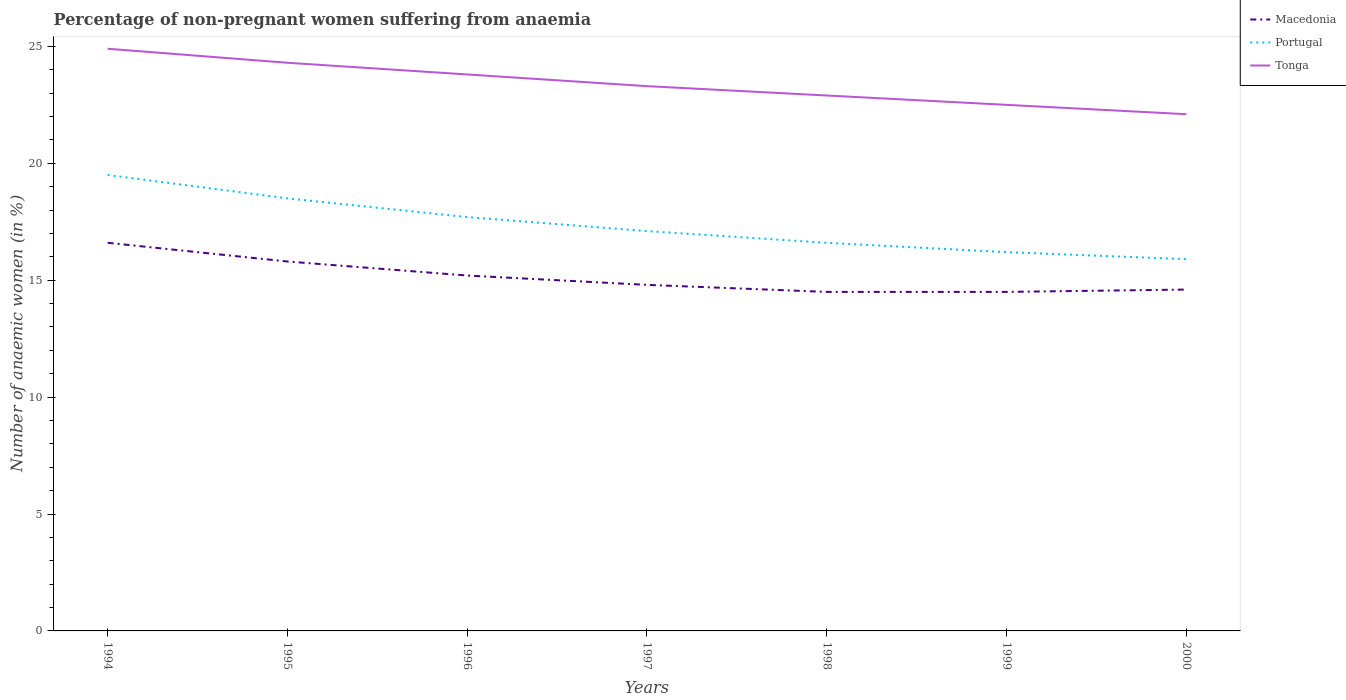How many different coloured lines are there?
Provide a short and direct response. 3. Is the number of lines equal to the number of legend labels?
Offer a very short reply. Yes. Across all years, what is the maximum percentage of non-pregnant women suffering from anaemia in Tonga?
Give a very brief answer. 22.1. What is the total percentage of non-pregnant women suffering from anaemia in Macedonia in the graph?
Keep it short and to the point. 1.4. What is the difference between the highest and the second highest percentage of non-pregnant women suffering from anaemia in Portugal?
Offer a very short reply. 3.6. How many years are there in the graph?
Make the answer very short. 7. What is the difference between two consecutive major ticks on the Y-axis?
Your answer should be very brief. 5. Does the graph contain any zero values?
Your answer should be very brief. No. Where does the legend appear in the graph?
Provide a short and direct response. Top right. How many legend labels are there?
Provide a succinct answer. 3. How are the legend labels stacked?
Keep it short and to the point. Vertical. What is the title of the graph?
Offer a very short reply. Percentage of non-pregnant women suffering from anaemia. What is the label or title of the Y-axis?
Offer a very short reply. Number of anaemic women (in %). What is the Number of anaemic women (in %) in Portugal in 1994?
Give a very brief answer. 19.5. What is the Number of anaemic women (in %) in Tonga in 1994?
Your answer should be very brief. 24.9. What is the Number of anaemic women (in %) of Macedonia in 1995?
Provide a short and direct response. 15.8. What is the Number of anaemic women (in %) of Tonga in 1995?
Your answer should be compact. 24.3. What is the Number of anaemic women (in %) in Macedonia in 1996?
Ensure brevity in your answer.  15.2. What is the Number of anaemic women (in %) in Tonga in 1996?
Make the answer very short. 23.8. What is the Number of anaemic women (in %) in Portugal in 1997?
Give a very brief answer. 17.1. What is the Number of anaemic women (in %) in Tonga in 1997?
Ensure brevity in your answer.  23.3. What is the Number of anaemic women (in %) in Macedonia in 1998?
Provide a short and direct response. 14.5. What is the Number of anaemic women (in %) of Portugal in 1998?
Your answer should be compact. 16.6. What is the Number of anaemic women (in %) in Tonga in 1998?
Ensure brevity in your answer.  22.9. What is the Number of anaemic women (in %) in Portugal in 1999?
Offer a very short reply. 16.2. What is the Number of anaemic women (in %) of Tonga in 2000?
Keep it short and to the point. 22.1. Across all years, what is the maximum Number of anaemic women (in %) of Macedonia?
Offer a terse response. 16.6. Across all years, what is the maximum Number of anaemic women (in %) in Portugal?
Keep it short and to the point. 19.5. Across all years, what is the maximum Number of anaemic women (in %) of Tonga?
Your answer should be compact. 24.9. Across all years, what is the minimum Number of anaemic women (in %) in Macedonia?
Provide a short and direct response. 14.5. Across all years, what is the minimum Number of anaemic women (in %) of Portugal?
Your answer should be compact. 15.9. Across all years, what is the minimum Number of anaemic women (in %) in Tonga?
Make the answer very short. 22.1. What is the total Number of anaemic women (in %) of Macedonia in the graph?
Keep it short and to the point. 106. What is the total Number of anaemic women (in %) in Portugal in the graph?
Keep it short and to the point. 121.5. What is the total Number of anaemic women (in %) of Tonga in the graph?
Offer a very short reply. 163.8. What is the difference between the Number of anaemic women (in %) in Tonga in 1994 and that in 1995?
Give a very brief answer. 0.6. What is the difference between the Number of anaemic women (in %) of Macedonia in 1994 and that in 1996?
Keep it short and to the point. 1.4. What is the difference between the Number of anaemic women (in %) of Portugal in 1994 and that in 1996?
Offer a very short reply. 1.8. What is the difference between the Number of anaemic women (in %) of Portugal in 1994 and that in 1997?
Provide a short and direct response. 2.4. What is the difference between the Number of anaemic women (in %) in Macedonia in 1994 and that in 1998?
Your response must be concise. 2.1. What is the difference between the Number of anaemic women (in %) of Portugal in 1994 and that in 1998?
Give a very brief answer. 2.9. What is the difference between the Number of anaemic women (in %) in Tonga in 1994 and that in 1998?
Give a very brief answer. 2. What is the difference between the Number of anaemic women (in %) in Portugal in 1994 and that in 1999?
Offer a terse response. 3.3. What is the difference between the Number of anaemic women (in %) in Portugal in 1995 and that in 1996?
Keep it short and to the point. 0.8. What is the difference between the Number of anaemic women (in %) in Tonga in 1995 and that in 1996?
Provide a succinct answer. 0.5. What is the difference between the Number of anaemic women (in %) in Macedonia in 1995 and that in 1997?
Ensure brevity in your answer.  1. What is the difference between the Number of anaemic women (in %) of Tonga in 1995 and that in 1997?
Provide a short and direct response. 1. What is the difference between the Number of anaemic women (in %) of Macedonia in 1995 and that in 1998?
Keep it short and to the point. 1.3. What is the difference between the Number of anaemic women (in %) of Macedonia in 1995 and that in 1999?
Your answer should be compact. 1.3. What is the difference between the Number of anaemic women (in %) in Tonga in 1995 and that in 1999?
Your answer should be compact. 1.8. What is the difference between the Number of anaemic women (in %) of Macedonia in 1995 and that in 2000?
Provide a short and direct response. 1.2. What is the difference between the Number of anaemic women (in %) of Tonga in 1995 and that in 2000?
Keep it short and to the point. 2.2. What is the difference between the Number of anaemic women (in %) in Tonga in 1996 and that in 1997?
Provide a short and direct response. 0.5. What is the difference between the Number of anaemic women (in %) of Portugal in 1996 and that in 1999?
Your response must be concise. 1.5. What is the difference between the Number of anaemic women (in %) of Tonga in 1996 and that in 1999?
Your answer should be very brief. 1.3. What is the difference between the Number of anaemic women (in %) of Macedonia in 1996 and that in 2000?
Give a very brief answer. 0.6. What is the difference between the Number of anaemic women (in %) in Tonga in 1997 and that in 1998?
Your answer should be very brief. 0.4. What is the difference between the Number of anaemic women (in %) in Macedonia in 1997 and that in 1999?
Ensure brevity in your answer.  0.3. What is the difference between the Number of anaemic women (in %) in Portugal in 1997 and that in 1999?
Give a very brief answer. 0.9. What is the difference between the Number of anaemic women (in %) in Tonga in 1997 and that in 1999?
Provide a succinct answer. 0.8. What is the difference between the Number of anaemic women (in %) of Macedonia in 1997 and that in 2000?
Make the answer very short. 0.2. What is the difference between the Number of anaemic women (in %) in Tonga in 1997 and that in 2000?
Your answer should be very brief. 1.2. What is the difference between the Number of anaemic women (in %) of Portugal in 1998 and that in 1999?
Provide a succinct answer. 0.4. What is the difference between the Number of anaemic women (in %) in Tonga in 1998 and that in 1999?
Give a very brief answer. 0.4. What is the difference between the Number of anaemic women (in %) of Tonga in 1998 and that in 2000?
Provide a succinct answer. 0.8. What is the difference between the Number of anaemic women (in %) in Macedonia in 1994 and the Number of anaemic women (in %) in Tonga in 1995?
Ensure brevity in your answer.  -7.7. What is the difference between the Number of anaemic women (in %) in Macedonia in 1994 and the Number of anaemic women (in %) in Portugal in 1996?
Your answer should be compact. -1.1. What is the difference between the Number of anaemic women (in %) in Macedonia in 1994 and the Number of anaemic women (in %) in Tonga in 1996?
Your response must be concise. -7.2. What is the difference between the Number of anaemic women (in %) of Macedonia in 1994 and the Number of anaemic women (in %) of Portugal in 1997?
Give a very brief answer. -0.5. What is the difference between the Number of anaemic women (in %) in Macedonia in 1994 and the Number of anaemic women (in %) in Tonga in 1997?
Offer a terse response. -6.7. What is the difference between the Number of anaemic women (in %) of Macedonia in 1994 and the Number of anaemic women (in %) of Portugal in 1998?
Ensure brevity in your answer.  0. What is the difference between the Number of anaemic women (in %) of Macedonia in 1994 and the Number of anaemic women (in %) of Tonga in 1999?
Your answer should be compact. -5.9. What is the difference between the Number of anaemic women (in %) in Macedonia in 1994 and the Number of anaemic women (in %) in Portugal in 2000?
Your answer should be very brief. 0.7. What is the difference between the Number of anaemic women (in %) in Portugal in 1994 and the Number of anaemic women (in %) in Tonga in 2000?
Offer a terse response. -2.6. What is the difference between the Number of anaemic women (in %) of Macedonia in 1995 and the Number of anaemic women (in %) of Tonga in 1996?
Keep it short and to the point. -8. What is the difference between the Number of anaemic women (in %) of Portugal in 1995 and the Number of anaemic women (in %) of Tonga in 1996?
Provide a succinct answer. -5.3. What is the difference between the Number of anaemic women (in %) of Macedonia in 1995 and the Number of anaemic women (in %) of Portugal in 1997?
Your answer should be very brief. -1.3. What is the difference between the Number of anaemic women (in %) of Macedonia in 1995 and the Number of anaemic women (in %) of Tonga in 1997?
Make the answer very short. -7.5. What is the difference between the Number of anaemic women (in %) in Macedonia in 1995 and the Number of anaemic women (in %) in Portugal in 1998?
Give a very brief answer. -0.8. What is the difference between the Number of anaemic women (in %) in Macedonia in 1995 and the Number of anaemic women (in %) in Tonga in 1998?
Offer a terse response. -7.1. What is the difference between the Number of anaemic women (in %) in Portugal in 1995 and the Number of anaemic women (in %) in Tonga in 1998?
Offer a terse response. -4.4. What is the difference between the Number of anaemic women (in %) of Portugal in 1995 and the Number of anaemic women (in %) of Tonga in 1999?
Provide a short and direct response. -4. What is the difference between the Number of anaemic women (in %) of Macedonia in 1995 and the Number of anaemic women (in %) of Portugal in 2000?
Give a very brief answer. -0.1. What is the difference between the Number of anaemic women (in %) of Macedonia in 1995 and the Number of anaemic women (in %) of Tonga in 2000?
Make the answer very short. -6.3. What is the difference between the Number of anaemic women (in %) of Macedonia in 1996 and the Number of anaemic women (in %) of Tonga in 1997?
Give a very brief answer. -8.1. What is the difference between the Number of anaemic women (in %) of Macedonia in 1996 and the Number of anaemic women (in %) of Tonga in 1998?
Provide a short and direct response. -7.7. What is the difference between the Number of anaemic women (in %) of Portugal in 1996 and the Number of anaemic women (in %) of Tonga in 1998?
Provide a succinct answer. -5.2. What is the difference between the Number of anaemic women (in %) of Macedonia in 1996 and the Number of anaemic women (in %) of Portugal in 2000?
Your answer should be very brief. -0.7. What is the difference between the Number of anaemic women (in %) of Macedonia in 1996 and the Number of anaemic women (in %) of Tonga in 2000?
Provide a short and direct response. -6.9. What is the difference between the Number of anaemic women (in %) in Portugal in 1996 and the Number of anaemic women (in %) in Tonga in 2000?
Ensure brevity in your answer.  -4.4. What is the difference between the Number of anaemic women (in %) of Macedonia in 1997 and the Number of anaemic women (in %) of Tonga in 1998?
Your answer should be very brief. -8.1. What is the difference between the Number of anaemic women (in %) of Portugal in 1997 and the Number of anaemic women (in %) of Tonga in 1999?
Your answer should be very brief. -5.4. What is the difference between the Number of anaemic women (in %) in Portugal in 1997 and the Number of anaemic women (in %) in Tonga in 2000?
Ensure brevity in your answer.  -5. What is the difference between the Number of anaemic women (in %) of Macedonia in 1998 and the Number of anaemic women (in %) of Portugal in 1999?
Your answer should be very brief. -1.7. What is the difference between the Number of anaemic women (in %) in Macedonia in 1998 and the Number of anaemic women (in %) in Tonga in 1999?
Provide a succinct answer. -8. What is the difference between the Number of anaemic women (in %) in Portugal in 1998 and the Number of anaemic women (in %) in Tonga in 1999?
Offer a terse response. -5.9. What is the difference between the Number of anaemic women (in %) in Macedonia in 1998 and the Number of anaemic women (in %) in Portugal in 2000?
Give a very brief answer. -1.4. What is the difference between the Number of anaemic women (in %) in Macedonia in 1998 and the Number of anaemic women (in %) in Tonga in 2000?
Offer a very short reply. -7.6. What is the difference between the Number of anaemic women (in %) of Portugal in 1998 and the Number of anaemic women (in %) of Tonga in 2000?
Your answer should be very brief. -5.5. What is the difference between the Number of anaemic women (in %) of Portugal in 1999 and the Number of anaemic women (in %) of Tonga in 2000?
Offer a terse response. -5.9. What is the average Number of anaemic women (in %) of Macedonia per year?
Your response must be concise. 15.14. What is the average Number of anaemic women (in %) in Portugal per year?
Your answer should be compact. 17.36. What is the average Number of anaemic women (in %) of Tonga per year?
Provide a succinct answer. 23.4. In the year 1994, what is the difference between the Number of anaemic women (in %) of Portugal and Number of anaemic women (in %) of Tonga?
Your answer should be very brief. -5.4. In the year 1995, what is the difference between the Number of anaemic women (in %) in Portugal and Number of anaemic women (in %) in Tonga?
Your answer should be compact. -5.8. In the year 1996, what is the difference between the Number of anaemic women (in %) in Macedonia and Number of anaemic women (in %) in Portugal?
Provide a succinct answer. -2.5. In the year 1996, what is the difference between the Number of anaemic women (in %) in Portugal and Number of anaemic women (in %) in Tonga?
Give a very brief answer. -6.1. In the year 1997, what is the difference between the Number of anaemic women (in %) in Macedonia and Number of anaemic women (in %) in Portugal?
Keep it short and to the point. -2.3. In the year 1997, what is the difference between the Number of anaemic women (in %) of Macedonia and Number of anaemic women (in %) of Tonga?
Provide a short and direct response. -8.5. In the year 1998, what is the difference between the Number of anaemic women (in %) in Macedonia and Number of anaemic women (in %) in Tonga?
Provide a short and direct response. -8.4. In the year 1999, what is the difference between the Number of anaemic women (in %) in Macedonia and Number of anaemic women (in %) in Portugal?
Offer a very short reply. -1.7. In the year 1999, what is the difference between the Number of anaemic women (in %) in Macedonia and Number of anaemic women (in %) in Tonga?
Keep it short and to the point. -8. In the year 1999, what is the difference between the Number of anaemic women (in %) of Portugal and Number of anaemic women (in %) of Tonga?
Make the answer very short. -6.3. In the year 2000, what is the difference between the Number of anaemic women (in %) of Portugal and Number of anaemic women (in %) of Tonga?
Keep it short and to the point. -6.2. What is the ratio of the Number of anaemic women (in %) of Macedonia in 1994 to that in 1995?
Your answer should be very brief. 1.05. What is the ratio of the Number of anaemic women (in %) in Portugal in 1994 to that in 1995?
Provide a succinct answer. 1.05. What is the ratio of the Number of anaemic women (in %) of Tonga in 1994 to that in 1995?
Offer a very short reply. 1.02. What is the ratio of the Number of anaemic women (in %) in Macedonia in 1994 to that in 1996?
Make the answer very short. 1.09. What is the ratio of the Number of anaemic women (in %) of Portugal in 1994 to that in 1996?
Provide a short and direct response. 1.1. What is the ratio of the Number of anaemic women (in %) of Tonga in 1994 to that in 1996?
Offer a very short reply. 1.05. What is the ratio of the Number of anaemic women (in %) in Macedonia in 1994 to that in 1997?
Provide a short and direct response. 1.12. What is the ratio of the Number of anaemic women (in %) of Portugal in 1994 to that in 1997?
Your answer should be compact. 1.14. What is the ratio of the Number of anaemic women (in %) of Tonga in 1994 to that in 1997?
Make the answer very short. 1.07. What is the ratio of the Number of anaemic women (in %) of Macedonia in 1994 to that in 1998?
Your response must be concise. 1.14. What is the ratio of the Number of anaemic women (in %) of Portugal in 1994 to that in 1998?
Keep it short and to the point. 1.17. What is the ratio of the Number of anaemic women (in %) in Tonga in 1994 to that in 1998?
Provide a succinct answer. 1.09. What is the ratio of the Number of anaemic women (in %) of Macedonia in 1994 to that in 1999?
Your response must be concise. 1.14. What is the ratio of the Number of anaemic women (in %) in Portugal in 1994 to that in 1999?
Offer a terse response. 1.2. What is the ratio of the Number of anaemic women (in %) in Tonga in 1994 to that in 1999?
Offer a terse response. 1.11. What is the ratio of the Number of anaemic women (in %) of Macedonia in 1994 to that in 2000?
Provide a succinct answer. 1.14. What is the ratio of the Number of anaemic women (in %) of Portugal in 1994 to that in 2000?
Ensure brevity in your answer.  1.23. What is the ratio of the Number of anaemic women (in %) in Tonga in 1994 to that in 2000?
Your answer should be compact. 1.13. What is the ratio of the Number of anaemic women (in %) in Macedonia in 1995 to that in 1996?
Keep it short and to the point. 1.04. What is the ratio of the Number of anaemic women (in %) in Portugal in 1995 to that in 1996?
Your response must be concise. 1.05. What is the ratio of the Number of anaemic women (in %) in Macedonia in 1995 to that in 1997?
Ensure brevity in your answer.  1.07. What is the ratio of the Number of anaemic women (in %) of Portugal in 1995 to that in 1997?
Provide a short and direct response. 1.08. What is the ratio of the Number of anaemic women (in %) in Tonga in 1995 to that in 1997?
Make the answer very short. 1.04. What is the ratio of the Number of anaemic women (in %) in Macedonia in 1995 to that in 1998?
Provide a short and direct response. 1.09. What is the ratio of the Number of anaemic women (in %) in Portugal in 1995 to that in 1998?
Provide a succinct answer. 1.11. What is the ratio of the Number of anaemic women (in %) of Tonga in 1995 to that in 1998?
Your response must be concise. 1.06. What is the ratio of the Number of anaemic women (in %) in Macedonia in 1995 to that in 1999?
Give a very brief answer. 1.09. What is the ratio of the Number of anaemic women (in %) of Portugal in 1995 to that in 1999?
Give a very brief answer. 1.14. What is the ratio of the Number of anaemic women (in %) in Macedonia in 1995 to that in 2000?
Offer a very short reply. 1.08. What is the ratio of the Number of anaemic women (in %) of Portugal in 1995 to that in 2000?
Give a very brief answer. 1.16. What is the ratio of the Number of anaemic women (in %) in Tonga in 1995 to that in 2000?
Provide a succinct answer. 1.1. What is the ratio of the Number of anaemic women (in %) of Portugal in 1996 to that in 1997?
Give a very brief answer. 1.04. What is the ratio of the Number of anaemic women (in %) of Tonga in 1996 to that in 1997?
Keep it short and to the point. 1.02. What is the ratio of the Number of anaemic women (in %) of Macedonia in 1996 to that in 1998?
Keep it short and to the point. 1.05. What is the ratio of the Number of anaemic women (in %) of Portugal in 1996 to that in 1998?
Offer a very short reply. 1.07. What is the ratio of the Number of anaemic women (in %) in Tonga in 1996 to that in 1998?
Your response must be concise. 1.04. What is the ratio of the Number of anaemic women (in %) of Macedonia in 1996 to that in 1999?
Your answer should be very brief. 1.05. What is the ratio of the Number of anaemic women (in %) of Portugal in 1996 to that in 1999?
Ensure brevity in your answer.  1.09. What is the ratio of the Number of anaemic women (in %) of Tonga in 1996 to that in 1999?
Provide a succinct answer. 1.06. What is the ratio of the Number of anaemic women (in %) of Macedonia in 1996 to that in 2000?
Keep it short and to the point. 1.04. What is the ratio of the Number of anaemic women (in %) of Portugal in 1996 to that in 2000?
Your answer should be compact. 1.11. What is the ratio of the Number of anaemic women (in %) of Tonga in 1996 to that in 2000?
Offer a terse response. 1.08. What is the ratio of the Number of anaemic women (in %) of Macedonia in 1997 to that in 1998?
Your answer should be very brief. 1.02. What is the ratio of the Number of anaemic women (in %) of Portugal in 1997 to that in 1998?
Your response must be concise. 1.03. What is the ratio of the Number of anaemic women (in %) of Tonga in 1997 to that in 1998?
Your answer should be compact. 1.02. What is the ratio of the Number of anaemic women (in %) of Macedonia in 1997 to that in 1999?
Give a very brief answer. 1.02. What is the ratio of the Number of anaemic women (in %) of Portugal in 1997 to that in 1999?
Your answer should be very brief. 1.06. What is the ratio of the Number of anaemic women (in %) of Tonga in 1997 to that in 1999?
Offer a terse response. 1.04. What is the ratio of the Number of anaemic women (in %) of Macedonia in 1997 to that in 2000?
Your answer should be compact. 1.01. What is the ratio of the Number of anaemic women (in %) in Portugal in 1997 to that in 2000?
Provide a succinct answer. 1.08. What is the ratio of the Number of anaemic women (in %) of Tonga in 1997 to that in 2000?
Make the answer very short. 1.05. What is the ratio of the Number of anaemic women (in %) in Portugal in 1998 to that in 1999?
Your answer should be very brief. 1.02. What is the ratio of the Number of anaemic women (in %) in Tonga in 1998 to that in 1999?
Give a very brief answer. 1.02. What is the ratio of the Number of anaemic women (in %) in Portugal in 1998 to that in 2000?
Provide a short and direct response. 1.04. What is the ratio of the Number of anaemic women (in %) in Tonga in 1998 to that in 2000?
Provide a short and direct response. 1.04. What is the ratio of the Number of anaemic women (in %) of Macedonia in 1999 to that in 2000?
Your answer should be very brief. 0.99. What is the ratio of the Number of anaemic women (in %) in Portugal in 1999 to that in 2000?
Make the answer very short. 1.02. What is the ratio of the Number of anaemic women (in %) in Tonga in 1999 to that in 2000?
Offer a terse response. 1.02. What is the difference between the highest and the second highest Number of anaemic women (in %) of Tonga?
Provide a short and direct response. 0.6. What is the difference between the highest and the lowest Number of anaemic women (in %) of Tonga?
Give a very brief answer. 2.8. 